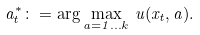<formula> <loc_0><loc_0><loc_500><loc_500>a ^ { * } _ { t } \colon = \arg \max _ { a = 1 \dots k } \, u ( x _ { t } , a ) .</formula> 